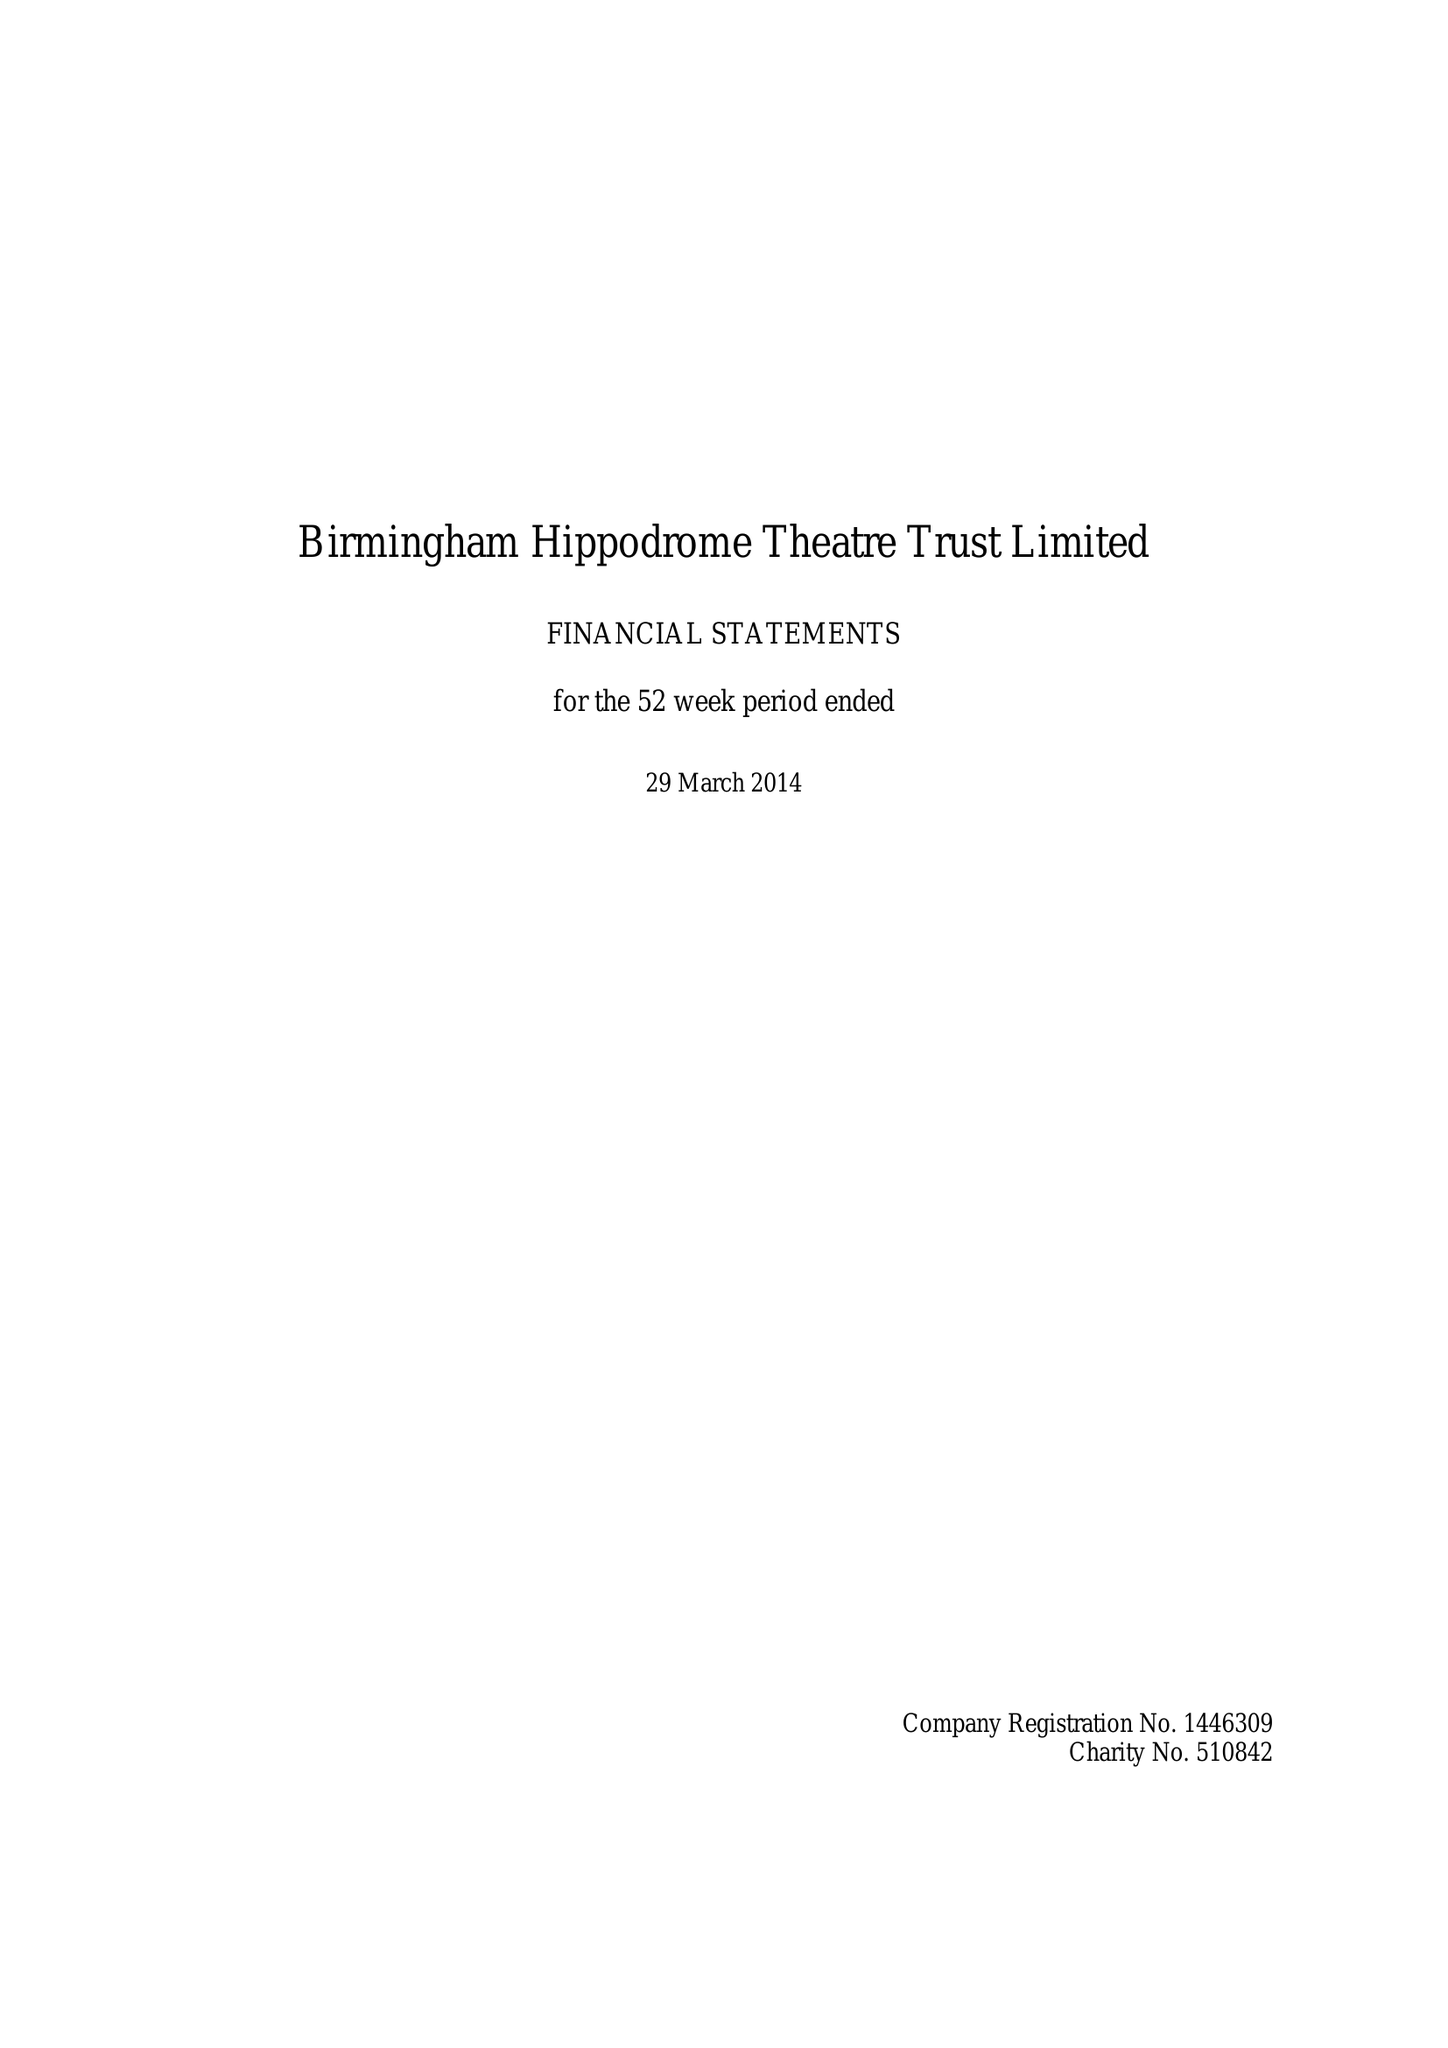What is the value for the income_annually_in_british_pounds?
Answer the question using a single word or phrase. 31563000.00 